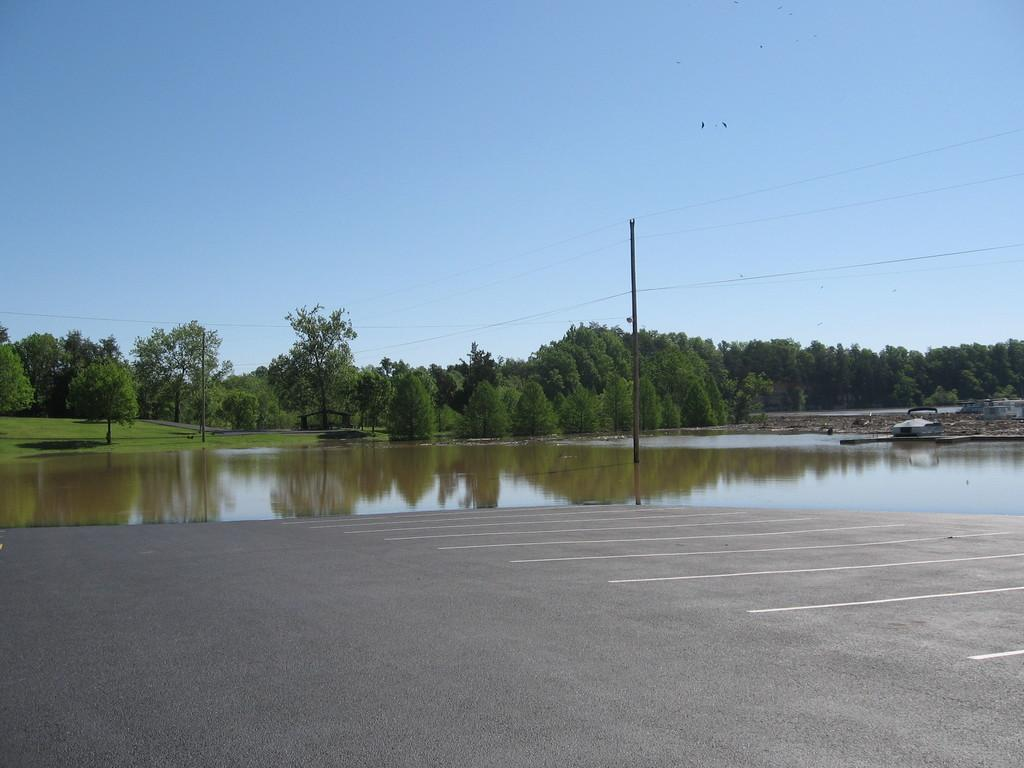What is the main feature in the center of the image? There is water in the center of the image. What is located at the bottom of the image? There is a road at the bottom of the image. What can be seen in the background of the image? There are trees and the sky visible in the background of the image. What structure is present in the image? There is a pole in the image, and it has wires associated with it. How does the image make you feel? The image itself does not have feelings, as it is a static representation. However, the viewer's feelings may vary based on their personal experiences and preferences. --- 